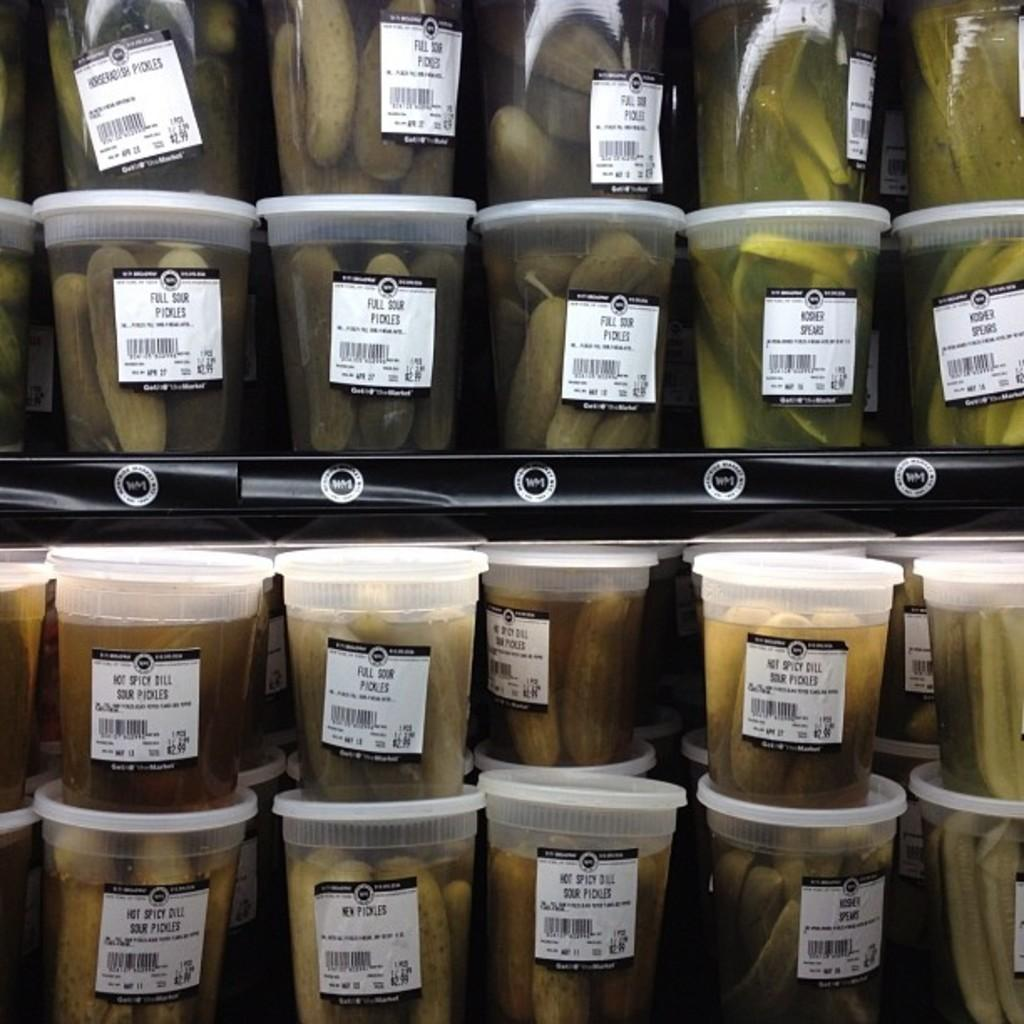What objects are visible in the image? There are containers in the image. What is inside the containers? The containers contain fruits. How can the contents of the containers be identified? There are tags on the containers with text on them. What type of berry is being protested in the image? There is no berry or protest present in the image; it only features containers with fruits and tags. 